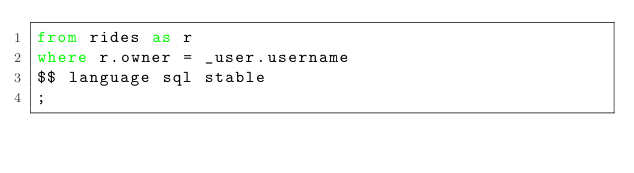<code> <loc_0><loc_0><loc_500><loc_500><_SQL_>from rides as r
where r.owner = _user.username
$$ language sql stable
;

</code> 